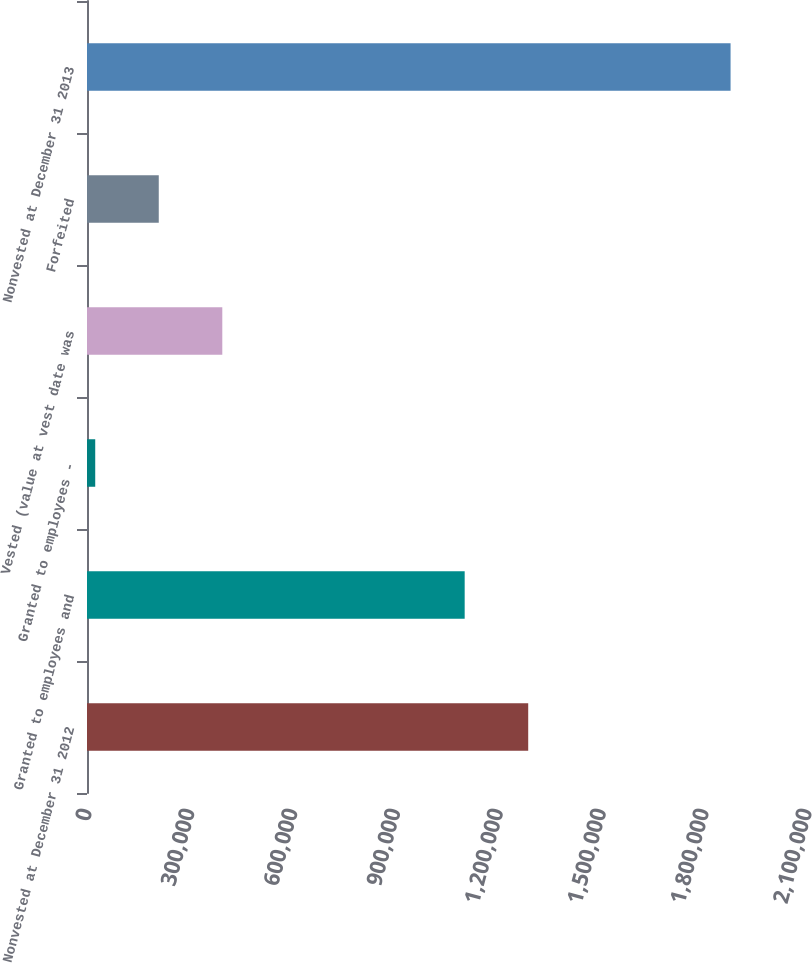Convert chart. <chart><loc_0><loc_0><loc_500><loc_500><bar_chart><fcel>Nonvested at December 31 2012<fcel>Granted to employees and<fcel>Granted to employees -<fcel>Vested (value at vest date was<fcel>Forfeited<fcel>Nonvested at December 31 2013<nl><fcel>1.28686e+06<fcel>1.10156e+06<fcel>24000<fcel>394617<fcel>209309<fcel>1.87709e+06<nl></chart> 